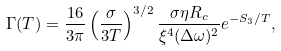<formula> <loc_0><loc_0><loc_500><loc_500>\Gamma ( T ) = \frac { 1 6 } { 3 \pi } \left ( \frac { \sigma } { 3 T } \right ) ^ { 3 / 2 } \frac { \sigma \eta R _ { c } } { \xi ^ { 4 } ( \Delta \omega ) ^ { 2 } } e ^ { - S _ { 3 } / T } ,</formula> 